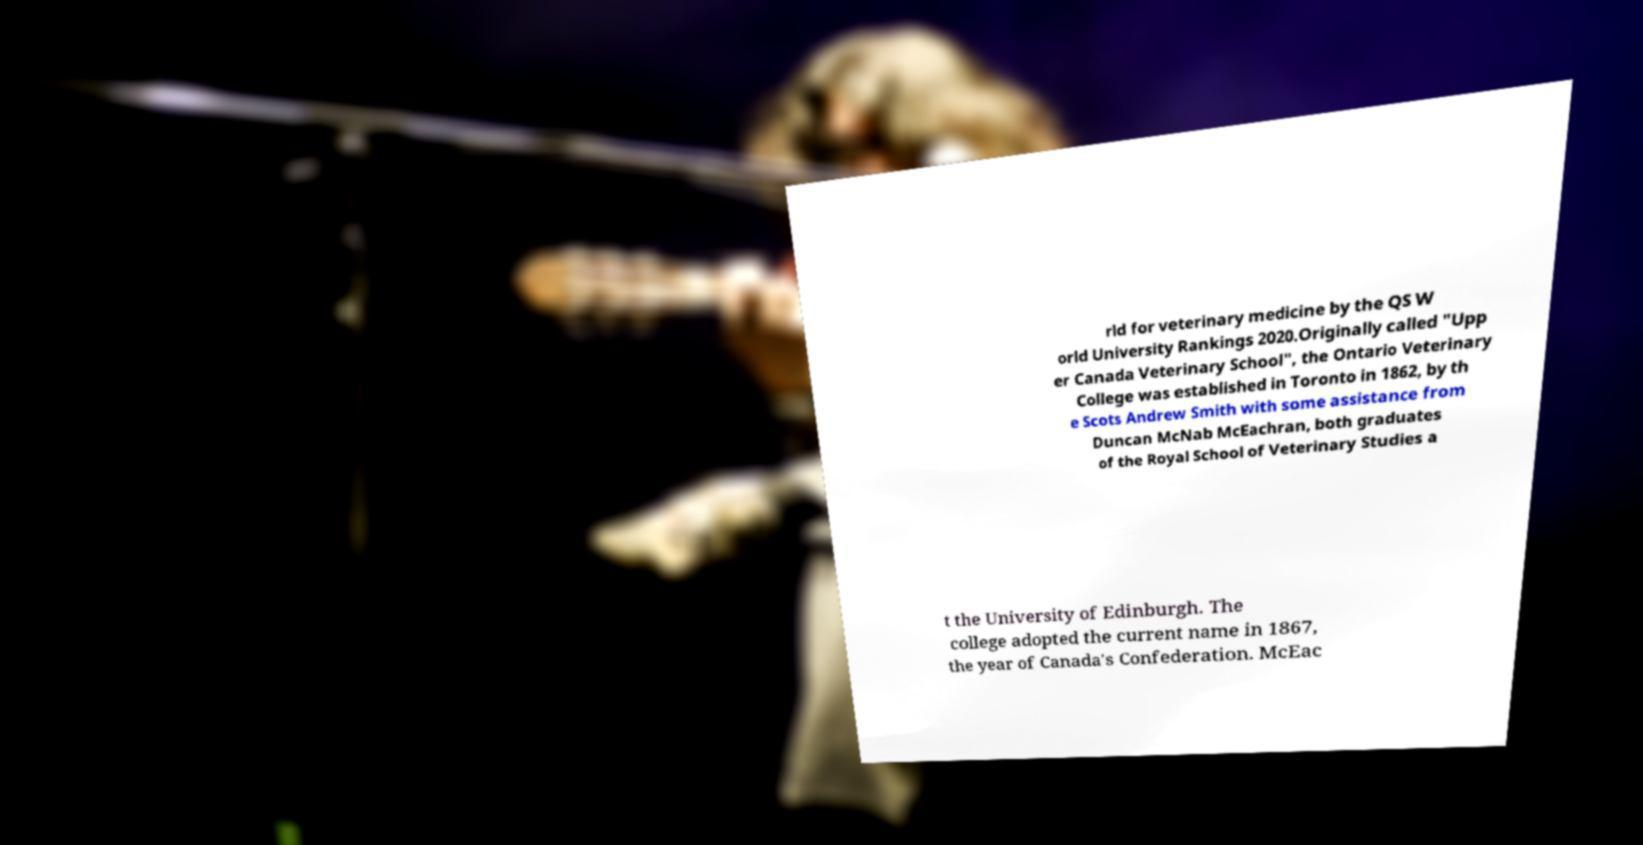Can you read and provide the text displayed in the image?This photo seems to have some interesting text. Can you extract and type it out for me? rld for veterinary medicine by the QS W orld University Rankings 2020.Originally called "Upp er Canada Veterinary School", the Ontario Veterinary College was established in Toronto in 1862, by th e Scots Andrew Smith with some assistance from Duncan McNab McEachran, both graduates of the Royal School of Veterinary Studies a t the University of Edinburgh. The college adopted the current name in 1867, the year of Canada's Confederation. McEac 